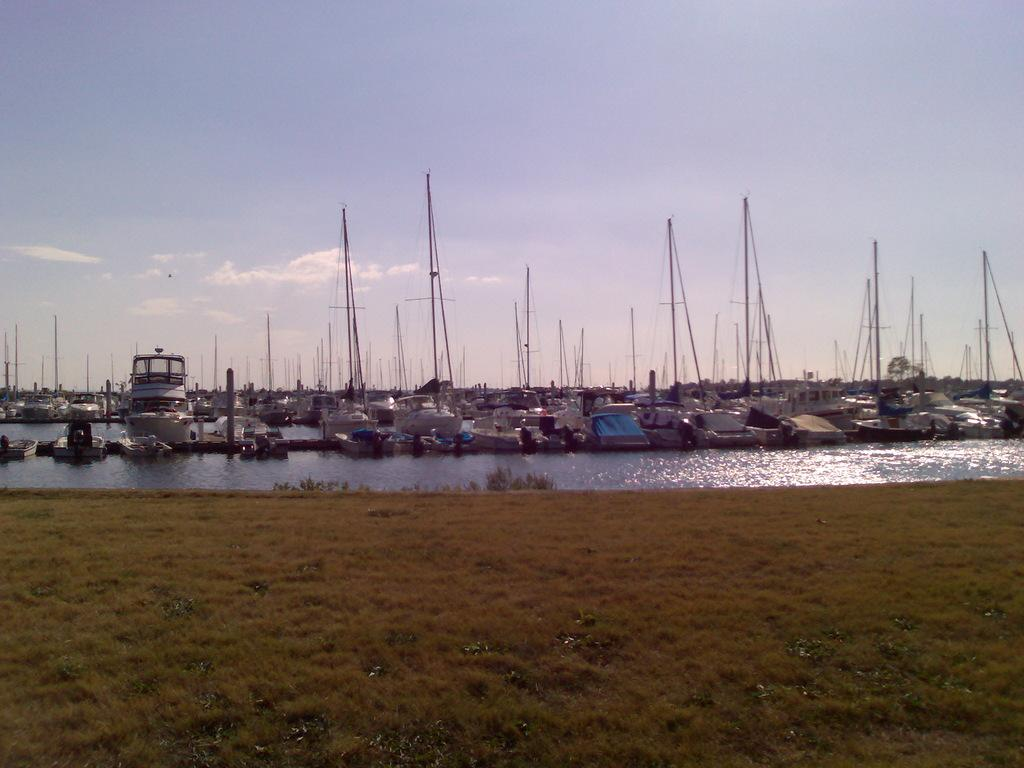What types of watercraft are in the image? There are boats and ships in the image. Where are the boats and ships located? They are on a river. What can be seen in the foreground of the image? The surface of the grass is visible in the foreground. What is visible in the background of the image? The sky is visible in the background. What type of drug can be seen in the image? There is no drug present in the image; it features boats and ships on a river, with grass in the foreground and the sky in the background. 